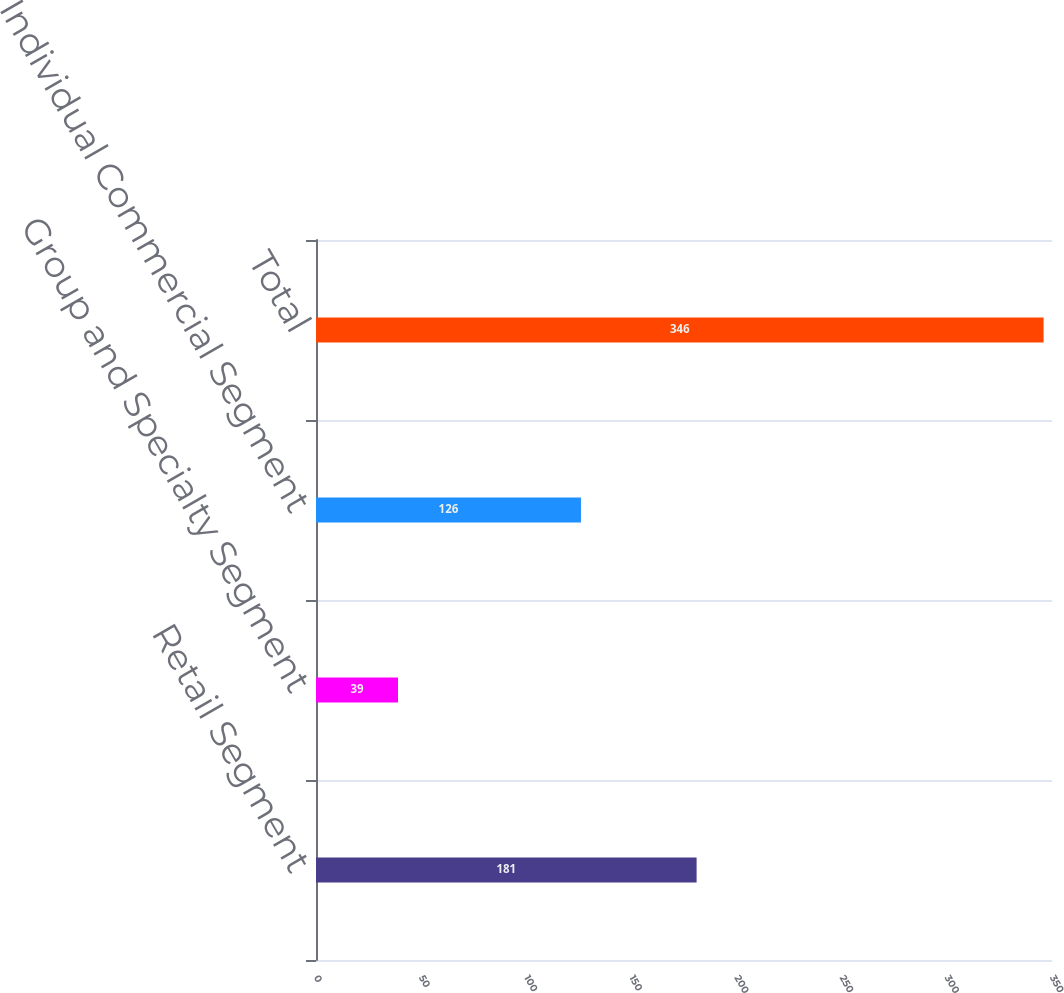Convert chart to OTSL. <chart><loc_0><loc_0><loc_500><loc_500><bar_chart><fcel>Retail Segment<fcel>Group and Specialty Segment<fcel>Individual Commercial Segment<fcel>Total<nl><fcel>181<fcel>39<fcel>126<fcel>346<nl></chart> 